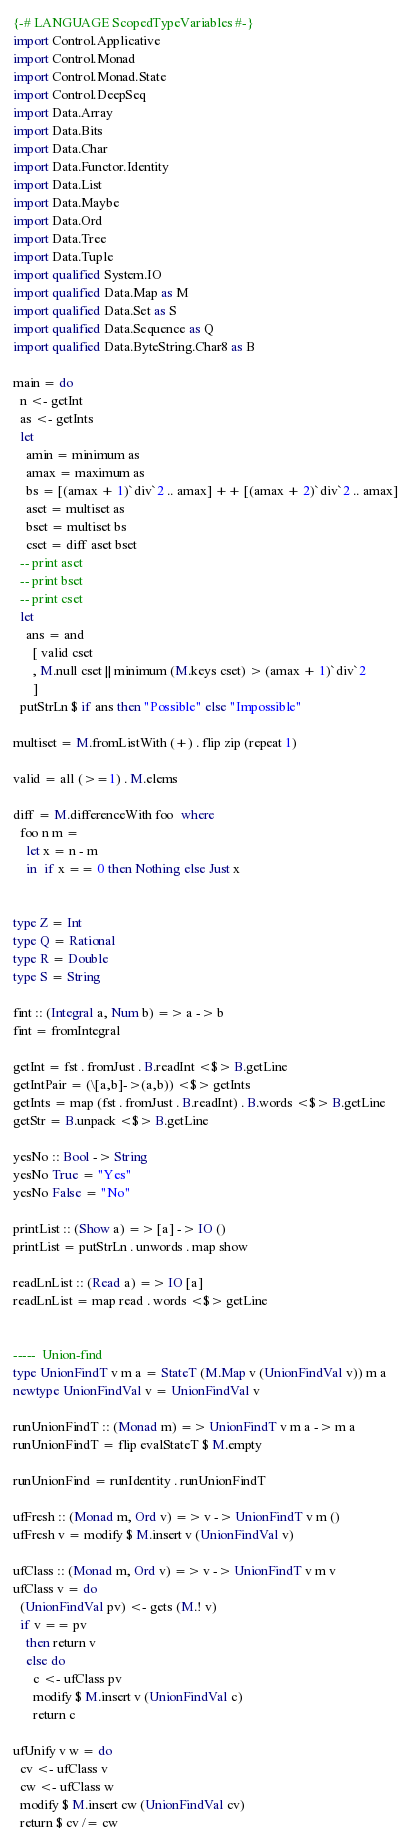Convert code to text. <code><loc_0><loc_0><loc_500><loc_500><_Haskell_>{-# LANGUAGE ScopedTypeVariables #-}
import Control.Applicative
import Control.Monad
import Control.Monad.State
import Control.DeepSeq
import Data.Array
import Data.Bits
import Data.Char
import Data.Functor.Identity
import Data.List
import Data.Maybe
import Data.Ord
import Data.Tree
import Data.Tuple
import qualified System.IO
import qualified Data.Map as M
import qualified Data.Set as S
import qualified Data.Sequence as Q
import qualified Data.ByteString.Char8 as B

main = do
  n <- getInt
  as <- getInts
  let
    amin = minimum as
    amax = maximum as
    bs = [(amax + 1)`div`2 .. amax] ++ [(amax + 2)`div`2 .. amax]
    aset = multiset as
    bset = multiset bs
    cset = diff aset bset
  -- print aset
  -- print bset
  -- print cset
  let
    ans = and
      [ valid cset
      , M.null cset || minimum (M.keys cset) > (amax + 1)`div`2
      ]
  putStrLn $ if ans then "Possible" else "Impossible"

multiset = M.fromListWith (+) . flip zip (repeat 1)

valid = all (>=1) . M.elems

diff = M.differenceWith foo  where
  foo n m =
    let x = n - m
    in  if x == 0 then Nothing else Just x

 
type Z = Int
type Q = Rational
type R = Double
type S = String

fint :: (Integral a, Num b) => a -> b
fint = fromIntegral

getInt = fst . fromJust . B.readInt <$> B.getLine
getIntPair = (\[a,b]->(a,b)) <$> getInts
getInts = map (fst . fromJust . B.readInt) . B.words <$> B.getLine
getStr = B.unpack <$> B.getLine

yesNo :: Bool -> String
yesNo True = "Yes"
yesNo False = "No"

printList :: (Show a) => [a] -> IO ()
printList = putStrLn . unwords . map show

readLnList :: (Read a) => IO [a]
readLnList = map read . words <$> getLine


-----  Union-find
type UnionFindT v m a = StateT (M.Map v (UnionFindVal v)) m a
newtype UnionFindVal v = UnionFindVal v

runUnionFindT :: (Monad m) => UnionFindT v m a -> m a
runUnionFindT = flip evalStateT $ M.empty

runUnionFind = runIdentity . runUnionFindT

ufFresh :: (Monad m, Ord v) => v -> UnionFindT v m ()
ufFresh v = modify $ M.insert v (UnionFindVal v)

ufClass :: (Monad m, Ord v) => v -> UnionFindT v m v
ufClass v = do
  (UnionFindVal pv) <- gets (M.! v)
  if v == pv
    then return v
    else do
      c <- ufClass pv
      modify $ M.insert v (UnionFindVal c)
      return c

ufUnify v w = do
  cv <- ufClass v
  cw <- ufClass w
  modify $ M.insert cw (UnionFindVal cv)
  return $ cv /= cw
</code> 